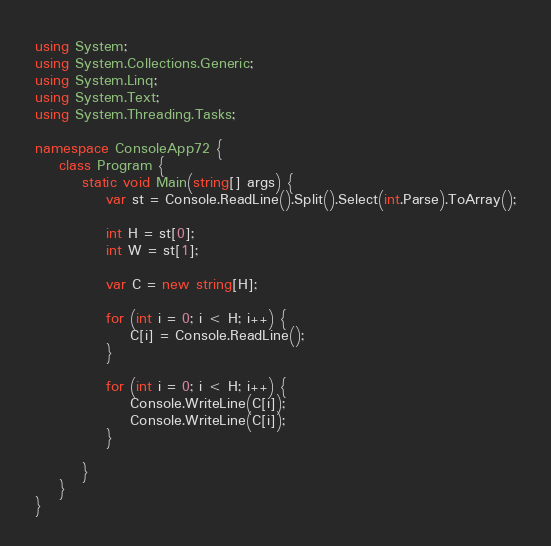<code> <loc_0><loc_0><loc_500><loc_500><_C#_>using System;
using System.Collections.Generic;
using System.Linq;
using System.Text;
using System.Threading.Tasks;

namespace ConsoleApp72 {
    class Program {
        static void Main(string[] args) {
            var st = Console.ReadLine().Split().Select(int.Parse).ToArray();

            int H = st[0];
            int W = st[1];

            var C = new string[H];

            for (int i = 0; i < H; i++) {
                C[i] = Console.ReadLine();
            }

            for (int i = 0; i < H; i++) {
                Console.WriteLine(C[i]);
                Console.WriteLine(C[i]);
            }

        }
    }
}
</code> 